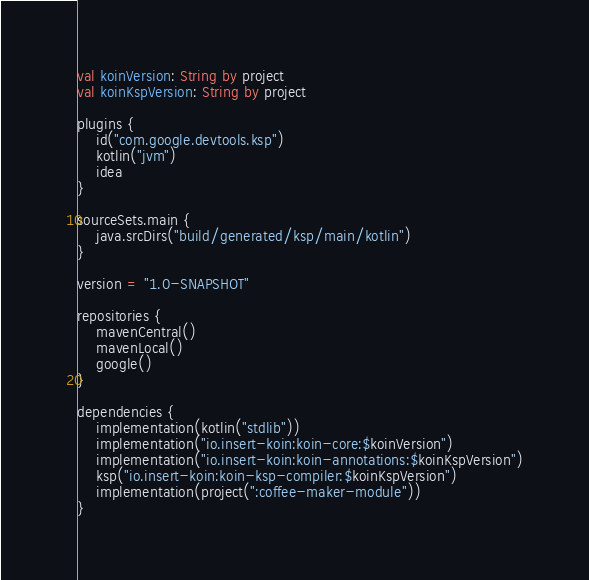<code> <loc_0><loc_0><loc_500><loc_500><_Kotlin_>val koinVersion: String by project
val koinKspVersion: String by project

plugins {
    id("com.google.devtools.ksp")
    kotlin("jvm")
    idea
}

sourceSets.main {
    java.srcDirs("build/generated/ksp/main/kotlin")
}

version = "1.0-SNAPSHOT"

repositories {
    mavenCentral()
    mavenLocal()
    google()
}

dependencies {
    implementation(kotlin("stdlib"))
    implementation("io.insert-koin:koin-core:$koinVersion")
    implementation("io.insert-koin:koin-annotations:$koinKspVersion")
    ksp("io.insert-koin:koin-ksp-compiler:$koinKspVersion")
    implementation(project(":coffee-maker-module"))
}
</code> 